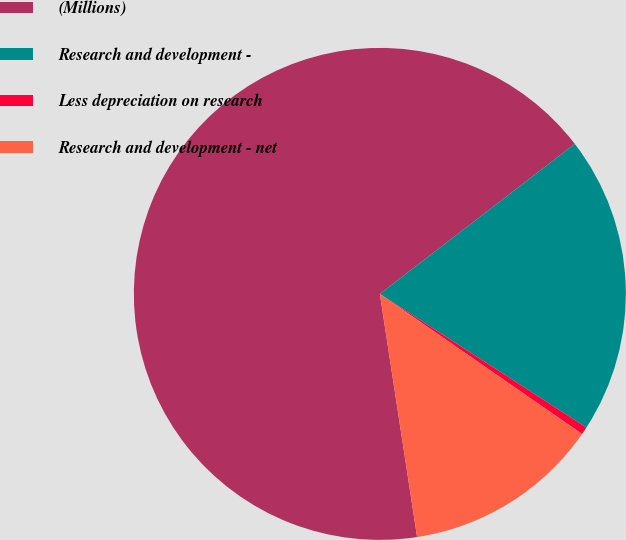Convert chart. <chart><loc_0><loc_0><loc_500><loc_500><pie_chart><fcel>(Millions)<fcel>Research and development -<fcel>Less depreciation on research<fcel>Research and development - net<nl><fcel>66.98%<fcel>19.58%<fcel>0.5%<fcel>12.94%<nl></chart> 